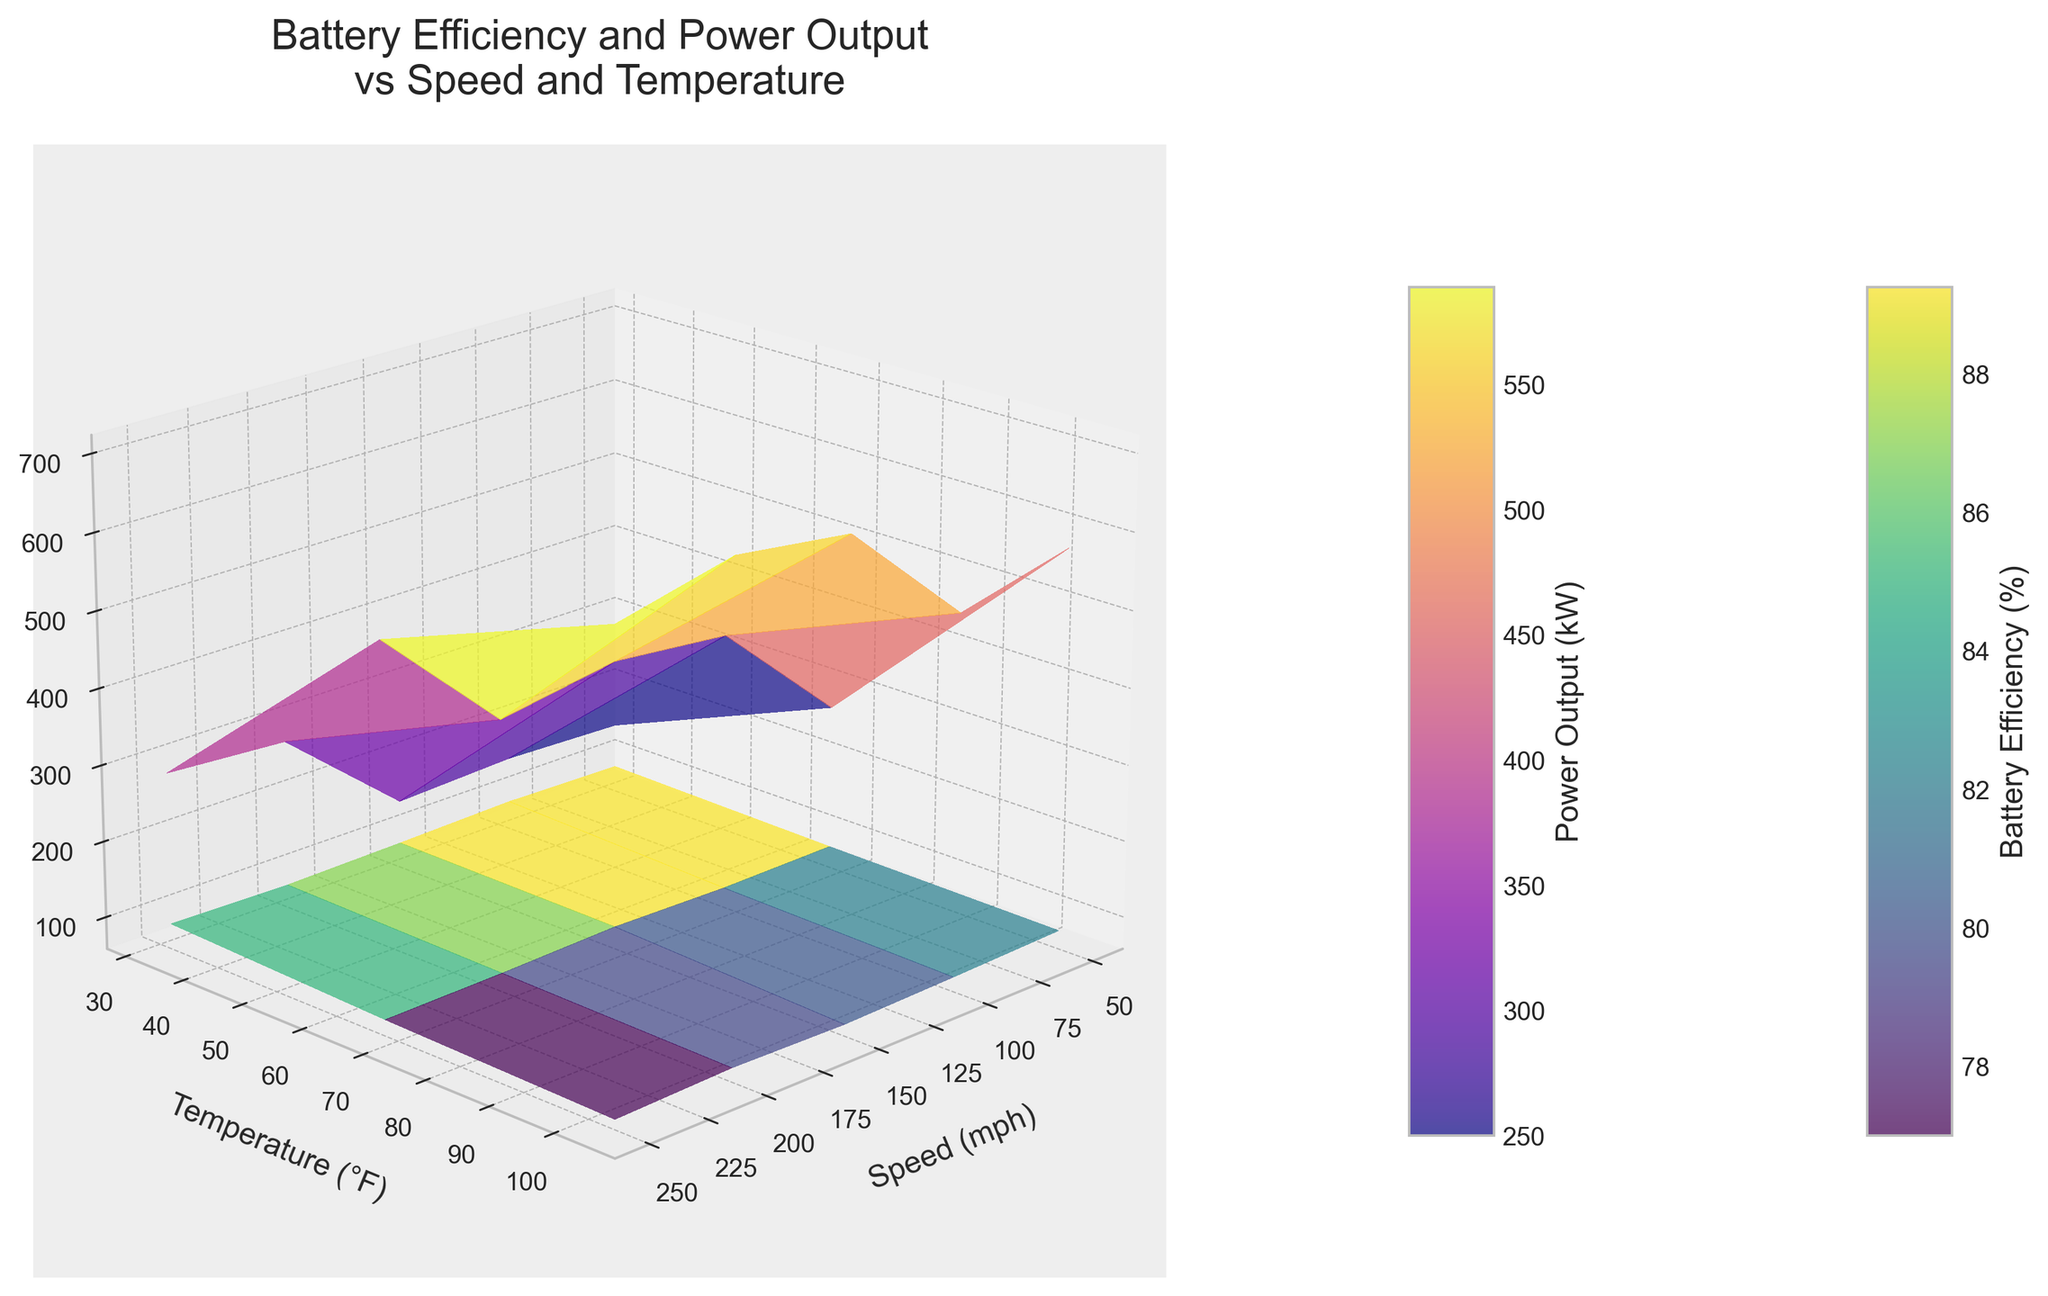What are the labels of the X, Y, and Z axes? The labels on the axes correspond to Speed (mph) for the X-axis, Temperature (°F) for the Y-axis, and Battery Efficiency (%) / Power (kW) for the Z-axis.
Answer: Speed (mph), Temperature (°F), Battery Efficiency (%) / Power (kW) How does battery efficiency change with increasing speed at 68°F? Inspect the surface representing Battery Efficiency (%). As speed increases from 50 to 250 mph at 68°F, the battery efficiency first increases slightly and then decreases.
Answer: Increases initially, then decreases What is the general trend for power output as speed increases at 104°F? Look at the surface representing Power Output (kW). At 104°F, as speed increases from 50 to 250 mph, power output also increases.
Answer: Increases Which temperature shows the highest battery efficiency at 100 mph? Examine the battery efficiency surface at 100 mph across different temperatures. The highest efficiency at 100 mph is observed at 68°F.
Answer: 68°F At what speed and temperature does the power output reach its maximum value in the figure? Check the surface representing Power Output (kW) for the peak value and note the corresponding speed and temperature. The maximum power output is at 250 mph and 68°F.
Answer: 250 mph, 68°F How does the battery efficiency at 32°F compare between 50 mph and 200 mph? Look at the battery efficiency values at 32°F for both 50 mph and 200 mph. At 50 mph, it is higher compared to 200 mph.
Answer: Higher at 50 mph Between the temperatures of 32°F and 104°F, which one generally leads to higher battery efficiency? By comparing the surfaces at these temperatures, it is generally seen that the battery efficiency is higher at 32°F compared to 104°F.
Answer: 32°F What is the relationship between speed and battery efficiency at 68°F? Is it direct or inverse? Inspect the trend of battery efficiency as speed increases at 68°F. The relationship starts direct with an increase at lower speeds but then inverses as it decreases at higher speeds.
Answer: Initial direct, then inverse At 150 mph, what happens to the power output as temperature changes from 32°F to 104°F? Look at the power output values at 150 mph for different temperatures. Power output decreases as the temperature increases from 32°F to 104°F.
Answer: Decreases What combination of speed and temperature yields the lowest battery efficiency? Identify the minimum efficiency on the battery efficiency surface and note the corresponding speed and temperature. The lowest battery efficiency is at 250 mph and 104°F.
Answer: 250 mph, 104°F 